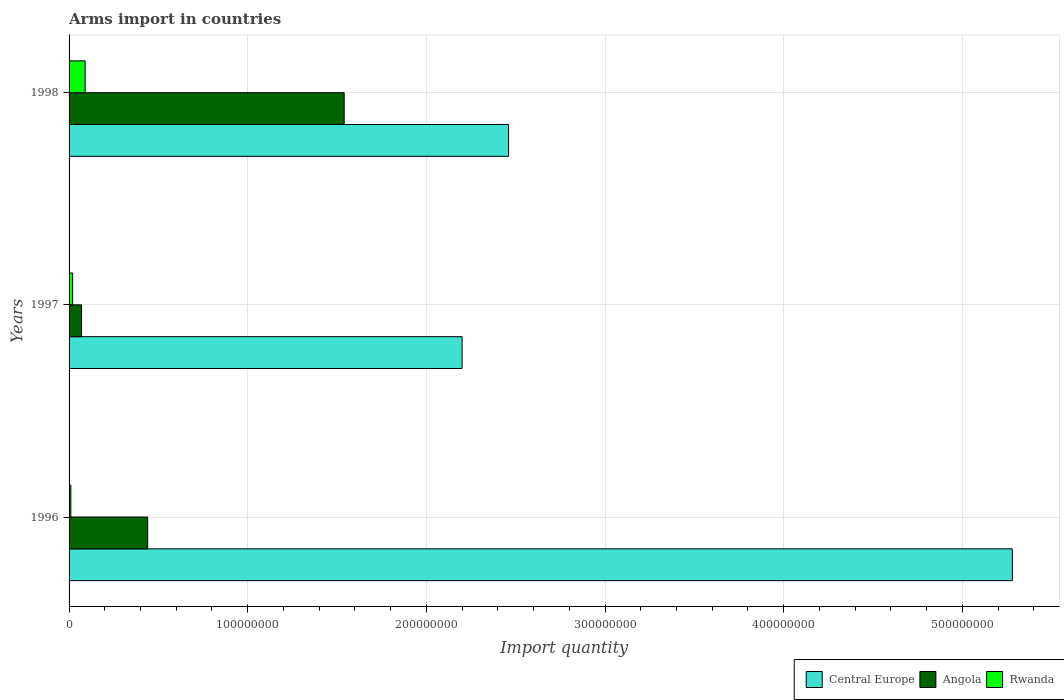How many different coloured bars are there?
Give a very brief answer. 3. How many groups of bars are there?
Provide a short and direct response. 3. Are the number of bars per tick equal to the number of legend labels?
Your answer should be very brief. Yes. What is the total arms import in Central Europe in 1998?
Your answer should be compact. 2.46e+08. Across all years, what is the maximum total arms import in Central Europe?
Make the answer very short. 5.28e+08. Across all years, what is the minimum total arms import in Central Europe?
Offer a very short reply. 2.20e+08. In which year was the total arms import in Rwanda maximum?
Your answer should be compact. 1998. In which year was the total arms import in Central Europe minimum?
Provide a succinct answer. 1997. What is the total total arms import in Central Europe in the graph?
Ensure brevity in your answer.  9.94e+08. What is the difference between the total arms import in Angola in 1997 and that in 1998?
Your response must be concise. -1.47e+08. What is the difference between the total arms import in Angola in 1996 and the total arms import in Rwanda in 1998?
Offer a very short reply. 3.50e+07. What is the average total arms import in Central Europe per year?
Your answer should be very brief. 3.31e+08. In the year 1997, what is the difference between the total arms import in Rwanda and total arms import in Central Europe?
Your answer should be very brief. -2.18e+08. What is the ratio of the total arms import in Angola in 1997 to that in 1998?
Provide a short and direct response. 0.05. Is the difference between the total arms import in Rwanda in 1996 and 1998 greater than the difference between the total arms import in Central Europe in 1996 and 1998?
Give a very brief answer. No. What is the difference between the highest and the second highest total arms import in Angola?
Give a very brief answer. 1.10e+08. What is the difference between the highest and the lowest total arms import in Angola?
Offer a very short reply. 1.47e+08. In how many years, is the total arms import in Central Europe greater than the average total arms import in Central Europe taken over all years?
Offer a very short reply. 1. What does the 2nd bar from the top in 1997 represents?
Keep it short and to the point. Angola. What does the 2nd bar from the bottom in 1997 represents?
Offer a very short reply. Angola. Is it the case that in every year, the sum of the total arms import in Rwanda and total arms import in Angola is greater than the total arms import in Central Europe?
Offer a very short reply. No. Are all the bars in the graph horizontal?
Provide a succinct answer. Yes. How many years are there in the graph?
Provide a succinct answer. 3. Does the graph contain grids?
Provide a short and direct response. Yes. Where does the legend appear in the graph?
Provide a short and direct response. Bottom right. What is the title of the graph?
Provide a short and direct response. Arms import in countries. What is the label or title of the X-axis?
Make the answer very short. Import quantity. What is the Import quantity of Central Europe in 1996?
Your answer should be compact. 5.28e+08. What is the Import quantity of Angola in 1996?
Your response must be concise. 4.40e+07. What is the Import quantity in Rwanda in 1996?
Make the answer very short. 1.00e+06. What is the Import quantity in Central Europe in 1997?
Offer a very short reply. 2.20e+08. What is the Import quantity in Central Europe in 1998?
Your answer should be compact. 2.46e+08. What is the Import quantity in Angola in 1998?
Make the answer very short. 1.54e+08. What is the Import quantity in Rwanda in 1998?
Give a very brief answer. 9.00e+06. Across all years, what is the maximum Import quantity in Central Europe?
Give a very brief answer. 5.28e+08. Across all years, what is the maximum Import quantity in Angola?
Keep it short and to the point. 1.54e+08. Across all years, what is the maximum Import quantity of Rwanda?
Give a very brief answer. 9.00e+06. Across all years, what is the minimum Import quantity of Central Europe?
Your response must be concise. 2.20e+08. Across all years, what is the minimum Import quantity in Angola?
Your response must be concise. 7.00e+06. What is the total Import quantity in Central Europe in the graph?
Give a very brief answer. 9.94e+08. What is the total Import quantity of Angola in the graph?
Provide a succinct answer. 2.05e+08. What is the total Import quantity in Rwanda in the graph?
Give a very brief answer. 1.20e+07. What is the difference between the Import quantity of Central Europe in 1996 and that in 1997?
Your answer should be compact. 3.08e+08. What is the difference between the Import quantity of Angola in 1996 and that in 1997?
Your response must be concise. 3.70e+07. What is the difference between the Import quantity of Central Europe in 1996 and that in 1998?
Your answer should be very brief. 2.82e+08. What is the difference between the Import quantity in Angola in 1996 and that in 1998?
Your answer should be compact. -1.10e+08. What is the difference between the Import quantity in Rwanda in 1996 and that in 1998?
Your response must be concise. -8.00e+06. What is the difference between the Import quantity in Central Europe in 1997 and that in 1998?
Offer a very short reply. -2.60e+07. What is the difference between the Import quantity in Angola in 1997 and that in 1998?
Offer a terse response. -1.47e+08. What is the difference between the Import quantity in Rwanda in 1997 and that in 1998?
Provide a succinct answer. -7.00e+06. What is the difference between the Import quantity in Central Europe in 1996 and the Import quantity in Angola in 1997?
Keep it short and to the point. 5.21e+08. What is the difference between the Import quantity of Central Europe in 1996 and the Import quantity of Rwanda in 1997?
Keep it short and to the point. 5.26e+08. What is the difference between the Import quantity in Angola in 1996 and the Import quantity in Rwanda in 1997?
Offer a very short reply. 4.20e+07. What is the difference between the Import quantity in Central Europe in 1996 and the Import quantity in Angola in 1998?
Give a very brief answer. 3.74e+08. What is the difference between the Import quantity in Central Europe in 1996 and the Import quantity in Rwanda in 1998?
Offer a very short reply. 5.19e+08. What is the difference between the Import quantity of Angola in 1996 and the Import quantity of Rwanda in 1998?
Give a very brief answer. 3.50e+07. What is the difference between the Import quantity in Central Europe in 1997 and the Import quantity in Angola in 1998?
Make the answer very short. 6.60e+07. What is the difference between the Import quantity in Central Europe in 1997 and the Import quantity in Rwanda in 1998?
Your answer should be very brief. 2.11e+08. What is the difference between the Import quantity in Angola in 1997 and the Import quantity in Rwanda in 1998?
Give a very brief answer. -2.00e+06. What is the average Import quantity in Central Europe per year?
Your answer should be very brief. 3.31e+08. What is the average Import quantity in Angola per year?
Your answer should be very brief. 6.83e+07. In the year 1996, what is the difference between the Import quantity of Central Europe and Import quantity of Angola?
Offer a terse response. 4.84e+08. In the year 1996, what is the difference between the Import quantity of Central Europe and Import quantity of Rwanda?
Your answer should be very brief. 5.27e+08. In the year 1996, what is the difference between the Import quantity of Angola and Import quantity of Rwanda?
Your response must be concise. 4.30e+07. In the year 1997, what is the difference between the Import quantity of Central Europe and Import quantity of Angola?
Your answer should be very brief. 2.13e+08. In the year 1997, what is the difference between the Import quantity of Central Europe and Import quantity of Rwanda?
Your answer should be very brief. 2.18e+08. In the year 1998, what is the difference between the Import quantity of Central Europe and Import quantity of Angola?
Your answer should be compact. 9.20e+07. In the year 1998, what is the difference between the Import quantity of Central Europe and Import quantity of Rwanda?
Offer a very short reply. 2.37e+08. In the year 1998, what is the difference between the Import quantity in Angola and Import quantity in Rwanda?
Keep it short and to the point. 1.45e+08. What is the ratio of the Import quantity in Central Europe in 1996 to that in 1997?
Keep it short and to the point. 2.4. What is the ratio of the Import quantity of Angola in 1996 to that in 1997?
Make the answer very short. 6.29. What is the ratio of the Import quantity of Rwanda in 1996 to that in 1997?
Your answer should be very brief. 0.5. What is the ratio of the Import quantity in Central Europe in 1996 to that in 1998?
Make the answer very short. 2.15. What is the ratio of the Import quantity of Angola in 1996 to that in 1998?
Keep it short and to the point. 0.29. What is the ratio of the Import quantity of Central Europe in 1997 to that in 1998?
Make the answer very short. 0.89. What is the ratio of the Import quantity of Angola in 1997 to that in 1998?
Offer a very short reply. 0.05. What is the ratio of the Import quantity in Rwanda in 1997 to that in 1998?
Ensure brevity in your answer.  0.22. What is the difference between the highest and the second highest Import quantity in Central Europe?
Provide a succinct answer. 2.82e+08. What is the difference between the highest and the second highest Import quantity in Angola?
Your answer should be compact. 1.10e+08. What is the difference between the highest and the second highest Import quantity of Rwanda?
Make the answer very short. 7.00e+06. What is the difference between the highest and the lowest Import quantity in Central Europe?
Offer a terse response. 3.08e+08. What is the difference between the highest and the lowest Import quantity of Angola?
Your answer should be very brief. 1.47e+08. What is the difference between the highest and the lowest Import quantity of Rwanda?
Offer a terse response. 8.00e+06. 